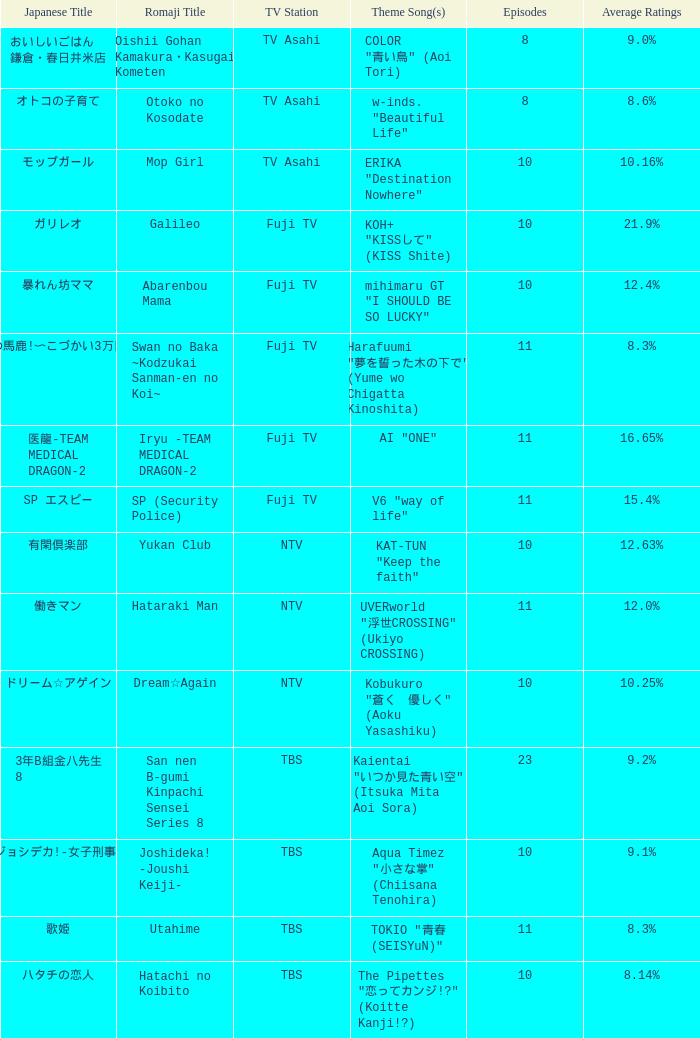Could you parse the entire table? {'header': ['Japanese Title', 'Romaji Title', 'TV Station', 'Theme Song(s)', 'Episodes', 'Average Ratings'], 'rows': [['おいしいごはん 鎌倉・春日井米店', 'Oishii Gohan Kamakura・Kasugai Kometen', 'TV Asahi', 'COLOR "青い鳥" (Aoi Tori)', '8', '9.0%'], ['オトコの子育て', 'Otoko no Kosodate', 'TV Asahi', 'w-inds. "Beautiful Life"', '8', '8.6%'], ['モップガール', 'Mop Girl', 'TV Asahi', 'ERIKA "Destination Nowhere"', '10', '10.16%'], ['ガリレオ', 'Galileo', 'Fuji TV', 'KOH+ "KISSして" (KISS Shite)', '10', '21.9%'], ['暴れん坊ママ', 'Abarenbou Mama', 'Fuji TV', 'mihimaru GT "I SHOULD BE SO LUCKY"', '10', '12.4%'], ['スワンの馬鹿!〜こづかい3万円の恋〜', 'Swan no Baka ~Kodzukai Sanman-en no Koi~', 'Fuji TV', 'Harafuumi "夢を誓った木の下で" (Yume wo Chigatta Kinoshita)', '11', '8.3%'], ['医龍-TEAM MEDICAL DRAGON-2', 'Iryu -TEAM MEDICAL DRAGON-2', 'Fuji TV', 'AI "ONE"', '11', '16.65%'], ['SP エスピー', 'SP (Security Police)', 'Fuji TV', 'V6 "way of life"', '11', '15.4%'], ['有閑倶楽部', 'Yukan Club', 'NTV', 'KAT-TUN "Keep the faith"', '10', '12.63%'], ['働きマン', 'Hataraki Man', 'NTV', 'UVERworld "浮世CROSSING" (Ukiyo CROSSING)', '11', '12.0%'], ['ドリーム☆アゲイン', 'Dream☆Again', 'NTV', 'Kobukuro "蒼く\u3000優しく" (Aoku Yasashiku)', '10', '10.25%'], ['3年B組金八先生 8', 'San nen B-gumi Kinpachi Sensei Series 8', 'TBS', 'Kaientai "いつか見た青い空" (Itsuka Mita Aoi Sora)', '23', '9.2%'], ['ジョシデカ!-女子刑事-', 'Joshideka! -Joushi Keiji-', 'TBS', 'Aqua Timez "小さな掌" (Chiisana Tenohira)', '10', '9.1%'], ['歌姫', 'Utahime', 'TBS', 'TOKIO "青春 (SEISYuN)"', '11', '8.3%'], ['ハタチの恋人', 'Hatachi no Koibito', 'TBS', 'The Pipettes "恋ってカンジ!?" (Koitte Kanji!?)', '10', '8.14%']]} 65%? AI "ONE". 